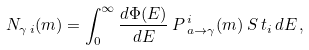Convert formula to latex. <formula><loc_0><loc_0><loc_500><loc_500>N _ { \gamma \, i } ( m ) = \int _ { 0 } ^ { \infty } \frac { d \Phi ( E ) } { d E } \, P \, ^ { i } _ { a \rightarrow \gamma } ( m ) \, S \, t _ { i } \, d E \, ,</formula> 